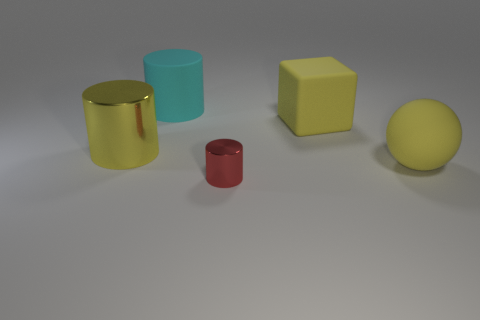Add 2 yellow rubber balls. How many objects exist? 7 Subtract all spheres. How many objects are left? 4 Subtract all metal cylinders. Subtract all big gray shiny cylinders. How many objects are left? 3 Add 5 small red cylinders. How many small red cylinders are left? 6 Add 3 cyan rubber things. How many cyan rubber things exist? 4 Subtract 1 cyan cylinders. How many objects are left? 4 